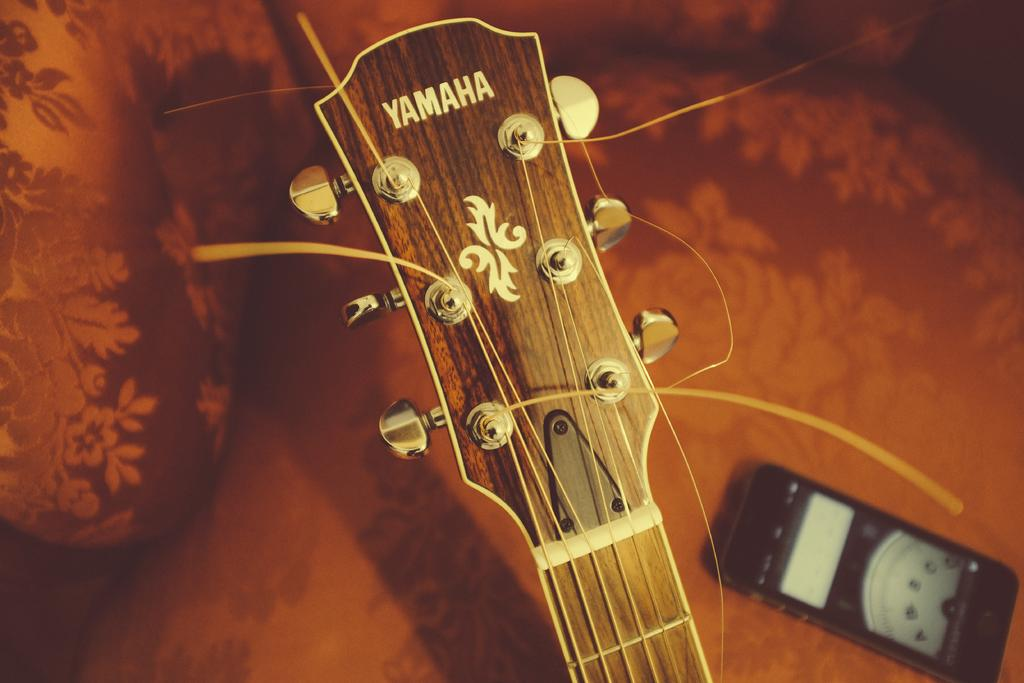What type of guitar is in the image? There is a Yamaha guitar in the image. What is the condition of the guitar's strings? The guitar has broken strings. Can you describe the background of the image? There is an instrument in the background of the image. What type of seed can be seen growing near the guitar in the image? There is no seed or plant visible near the guitar in the image. 